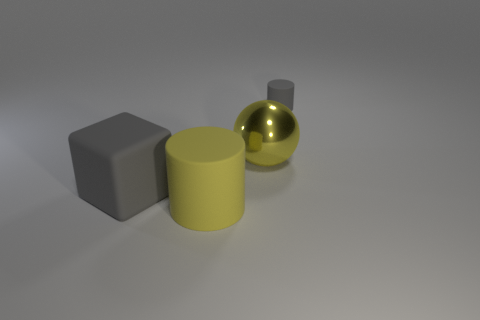What materials do these objects appear to be made of? Based on the visual qualities in the image, the objects appear to be made of different materials. The grey block seems to be made of a matte rubber-like material, the yellow cylinder could be made of a plastic or painted metal due to its glossy surface, and the sphere behind it has a reflective finish that suggests it could be a polished metal or glass. 